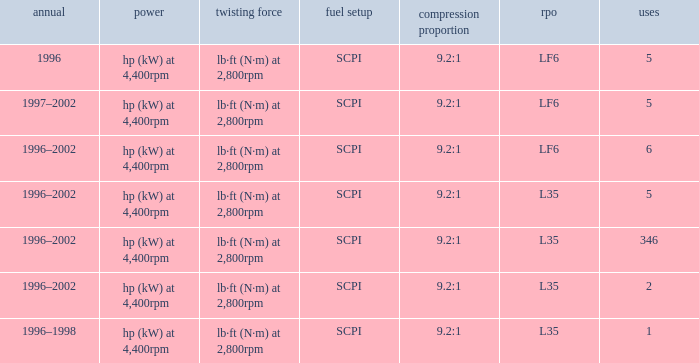What's the compression ratio of the model with L35 RPO and 5 applications? 9.2:1. Would you be able to parse every entry in this table? {'header': ['annual', 'power', 'twisting force', 'fuel setup', 'compression proportion', 'rpo', 'uses'], 'rows': [['1996', 'hp (kW) at 4,400rpm', 'lb·ft (N·m) at 2,800rpm', 'SCPI', '9.2:1', 'LF6', '5'], ['1997–2002', 'hp (kW) at 4,400rpm', 'lb·ft (N·m) at 2,800rpm', 'SCPI', '9.2:1', 'LF6', '5'], ['1996–2002', 'hp (kW) at 4,400rpm', 'lb·ft (N·m) at 2,800rpm', 'SCPI', '9.2:1', 'LF6', '6'], ['1996–2002', 'hp (kW) at 4,400rpm', 'lb·ft (N·m) at 2,800rpm', 'SCPI', '9.2:1', 'L35', '5'], ['1996–2002', 'hp (kW) at 4,400rpm', 'lb·ft (N·m) at 2,800rpm', 'SCPI', '9.2:1', 'L35', '346'], ['1996–2002', 'hp (kW) at 4,400rpm', 'lb·ft (N·m) at 2,800rpm', 'SCPI', '9.2:1', 'L35', '2'], ['1996–1998', 'hp (kW) at 4,400rpm', 'lb·ft (N·m) at 2,800rpm', 'SCPI', '9.2:1', 'L35', '1']]} 